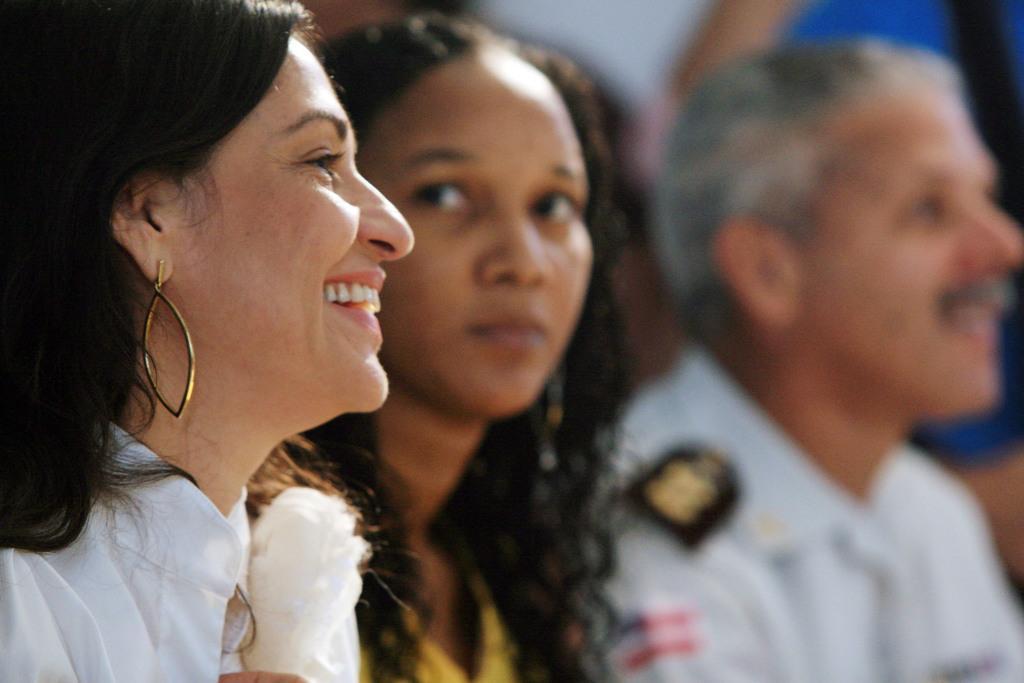In one or two sentences, can you explain what this image depicts? On the left side of the image we can see a woman and she is smiling. Here we can see two persons. There is a blur background. 